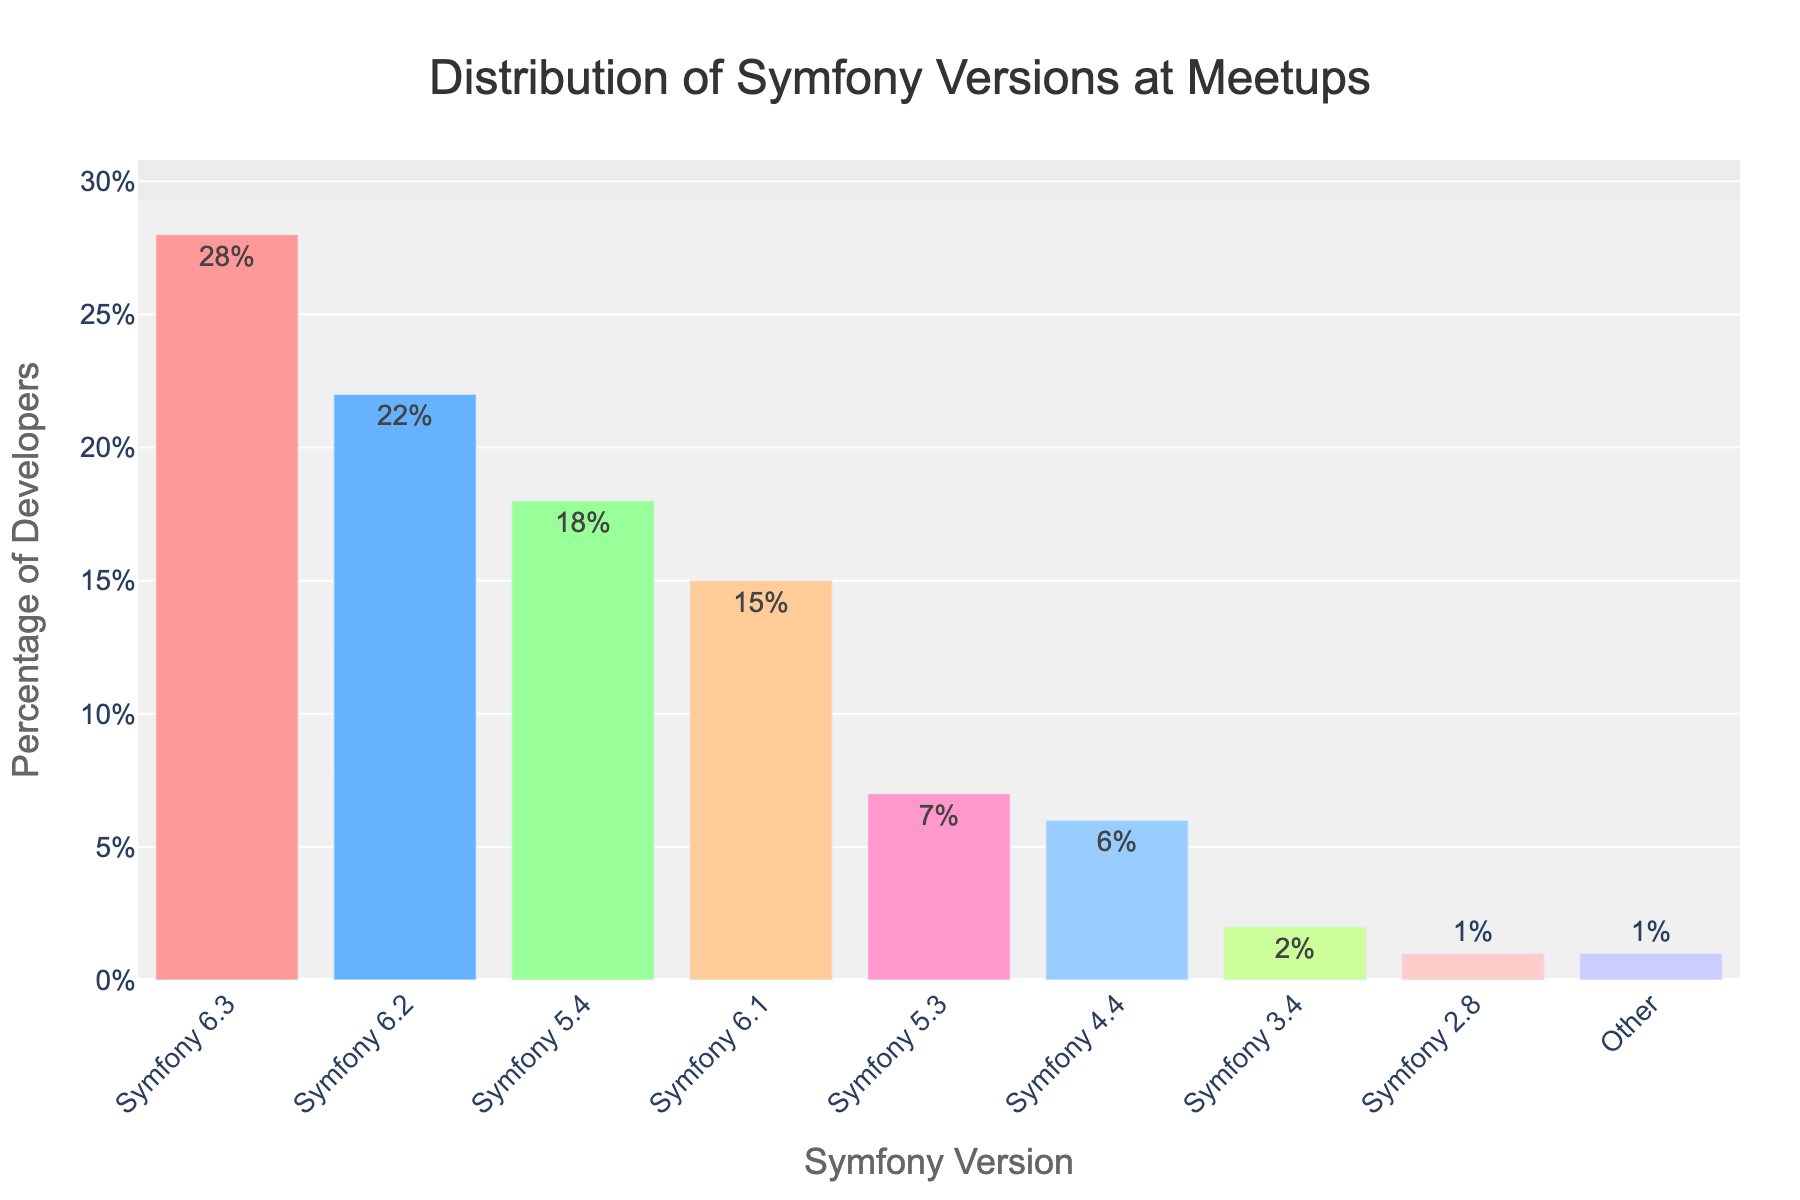What's the most commonly used Symfony version among developers attending the meetups? The bar chart shows various Symfony versions and their corresponding percentages. The tallest bar represents Symfony 6.3, with the highest percentage at 28%.
Answer: Symfony 6.3 What is the combined percentage of developers using Symfony versions 6.3 and 6.2? The percentages for Symfony 6.3 and 6.2 are 28% and 22%, respectively. Adding these gives 28% + 22% = 50%.
Answer: 50% Which Symfony version has a lower usage: Symfony 5.3 or Symfony 4.4? The bar chart displays percentages for each version. Symfony 5.3 has a usage of 7%, while Symfony 4.4 has a usage of 6%. Comparing these two percentages, Symfony 4.4 has the lower usage.
Answer: Symfony 4.4 How does the percentage of developers using Symfony 6.1 compare to those using Symfony 5.4? The bar chart indicates that 15% of developers use Symfony 6.1 and 18% use Symfony 5.4. Comparatively, Symfony 6.1 has a lower percentage of usage than Symfony 5.4.
Answer: Symfony 6.1 has a lower percentage What is the total percentage of developers using Symfony versions 5.4, 5.3, and 4.4? The percentages for Symfony 5.4, 5.3, and 4.4 are 18%, 7%, and 6%, respectively. Adding these yields 18% + 7% + 6% = 31%.
Answer: 31% What's the difference in usage between the version with the highest percentage and the version with the lowest percentage? The version with the highest usage is Symfony 6.3 (28%) and the version with the lowest usage is Symfony 2.8 (1%). The difference is 28% - 1% = 27%.
Answer: 27% How many more developers use Symfony 6.3 than Symfony 3.4? Symfony 6.3 has a usage of 28%, while Symfony 3.4 has a usage of 2%. The difference is 28% - 2% = 26%.
Answer: 26% Which bar is visually the shortest in the chart? The bar chart displays the shortest bar for Symfony 2.8, with a percentage of 1%.
Answer: Symfony 2.8 